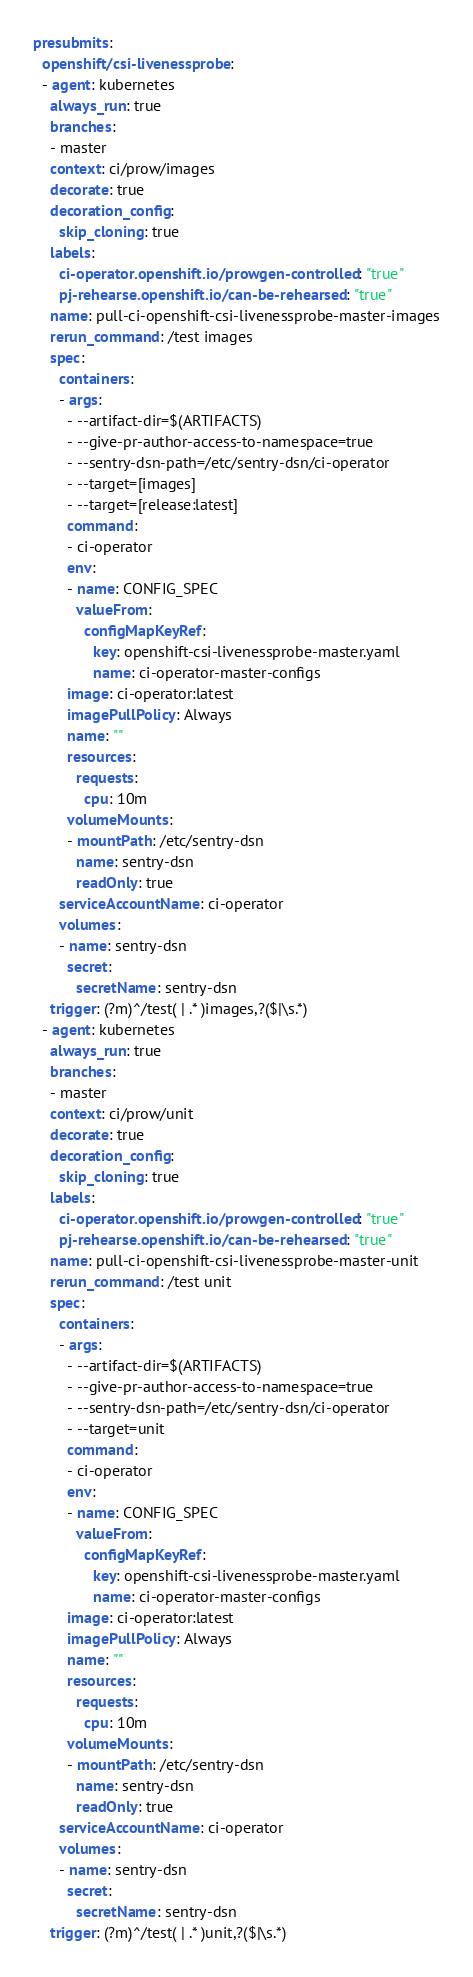Convert code to text. <code><loc_0><loc_0><loc_500><loc_500><_YAML_>presubmits:
  openshift/csi-livenessprobe:
  - agent: kubernetes
    always_run: true
    branches:
    - master
    context: ci/prow/images
    decorate: true
    decoration_config:
      skip_cloning: true
    labels:
      ci-operator.openshift.io/prowgen-controlled: "true"
      pj-rehearse.openshift.io/can-be-rehearsed: "true"
    name: pull-ci-openshift-csi-livenessprobe-master-images
    rerun_command: /test images
    spec:
      containers:
      - args:
        - --artifact-dir=$(ARTIFACTS)
        - --give-pr-author-access-to-namespace=true
        - --sentry-dsn-path=/etc/sentry-dsn/ci-operator
        - --target=[images]
        - --target=[release:latest]
        command:
        - ci-operator
        env:
        - name: CONFIG_SPEC
          valueFrom:
            configMapKeyRef:
              key: openshift-csi-livenessprobe-master.yaml
              name: ci-operator-master-configs
        image: ci-operator:latest
        imagePullPolicy: Always
        name: ""
        resources:
          requests:
            cpu: 10m
        volumeMounts:
        - mountPath: /etc/sentry-dsn
          name: sentry-dsn
          readOnly: true
      serviceAccountName: ci-operator
      volumes:
      - name: sentry-dsn
        secret:
          secretName: sentry-dsn
    trigger: (?m)^/test( | .* )images,?($|\s.*)
  - agent: kubernetes
    always_run: true
    branches:
    - master
    context: ci/prow/unit
    decorate: true
    decoration_config:
      skip_cloning: true
    labels:
      ci-operator.openshift.io/prowgen-controlled: "true"
      pj-rehearse.openshift.io/can-be-rehearsed: "true"
    name: pull-ci-openshift-csi-livenessprobe-master-unit
    rerun_command: /test unit
    spec:
      containers:
      - args:
        - --artifact-dir=$(ARTIFACTS)
        - --give-pr-author-access-to-namespace=true
        - --sentry-dsn-path=/etc/sentry-dsn/ci-operator
        - --target=unit
        command:
        - ci-operator
        env:
        - name: CONFIG_SPEC
          valueFrom:
            configMapKeyRef:
              key: openshift-csi-livenessprobe-master.yaml
              name: ci-operator-master-configs
        image: ci-operator:latest
        imagePullPolicy: Always
        name: ""
        resources:
          requests:
            cpu: 10m
        volumeMounts:
        - mountPath: /etc/sentry-dsn
          name: sentry-dsn
          readOnly: true
      serviceAccountName: ci-operator
      volumes:
      - name: sentry-dsn
        secret:
          secretName: sentry-dsn
    trigger: (?m)^/test( | .* )unit,?($|\s.*)
</code> 